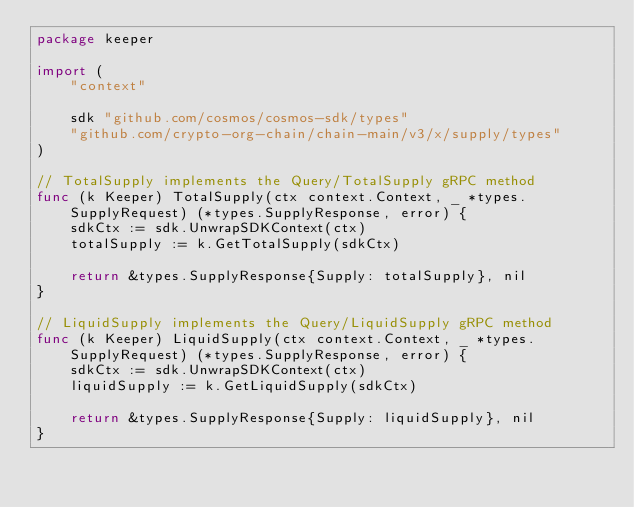<code> <loc_0><loc_0><loc_500><loc_500><_Go_>package keeper

import (
	"context"

	sdk "github.com/cosmos/cosmos-sdk/types"
	"github.com/crypto-org-chain/chain-main/v3/x/supply/types"
)

// TotalSupply implements the Query/TotalSupply gRPC method
func (k Keeper) TotalSupply(ctx context.Context, _ *types.SupplyRequest) (*types.SupplyResponse, error) {
	sdkCtx := sdk.UnwrapSDKContext(ctx)
	totalSupply := k.GetTotalSupply(sdkCtx)

	return &types.SupplyResponse{Supply: totalSupply}, nil
}

// LiquidSupply implements the Query/LiquidSupply gRPC method
func (k Keeper) LiquidSupply(ctx context.Context, _ *types.SupplyRequest) (*types.SupplyResponse, error) {
	sdkCtx := sdk.UnwrapSDKContext(ctx)
	liquidSupply := k.GetLiquidSupply(sdkCtx)

	return &types.SupplyResponse{Supply: liquidSupply}, nil
}
</code> 